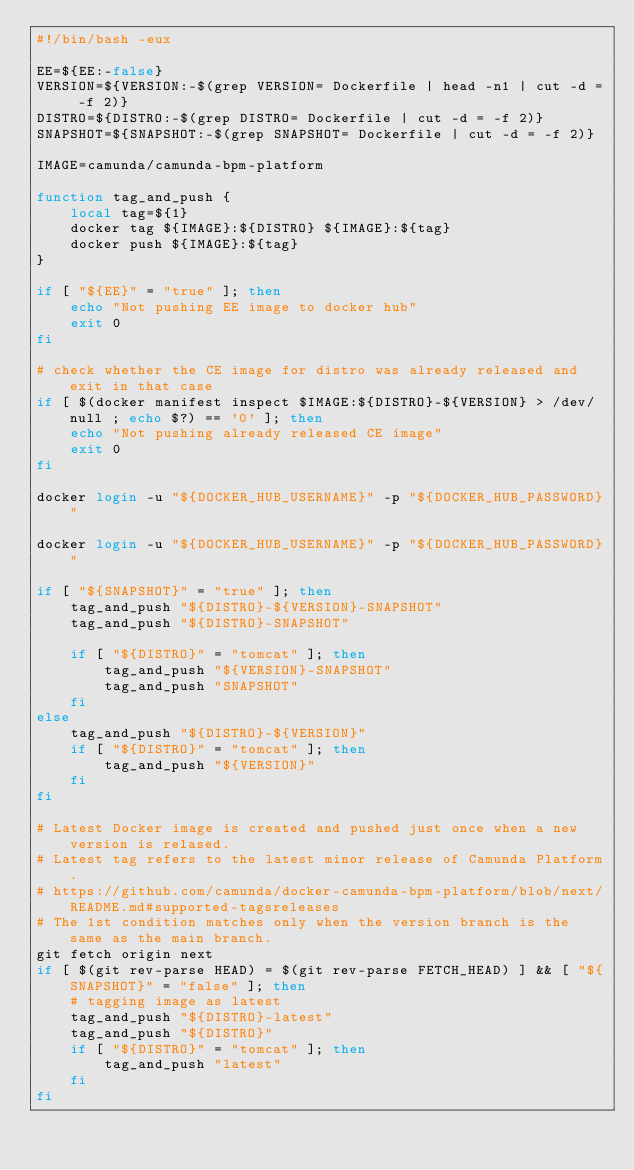Convert code to text. <code><loc_0><loc_0><loc_500><loc_500><_Bash_>#!/bin/bash -eux

EE=${EE:-false}
VERSION=${VERSION:-$(grep VERSION= Dockerfile | head -n1 | cut -d = -f 2)}
DISTRO=${DISTRO:-$(grep DISTRO= Dockerfile | cut -d = -f 2)}
SNAPSHOT=${SNAPSHOT:-$(grep SNAPSHOT= Dockerfile | cut -d = -f 2)}

IMAGE=camunda/camunda-bpm-platform

function tag_and_push {
    local tag=${1}
    docker tag ${IMAGE}:${DISTRO} ${IMAGE}:${tag}
    docker push ${IMAGE}:${tag}
}

if [ "${EE}" = "true" ]; then
    echo "Not pushing EE image to docker hub"
    exit 0
fi

# check whether the CE image for distro was already released and exit in that case
if [ $(docker manifest inspect $IMAGE:${DISTRO}-${VERSION} > /dev/null ; echo $?) == '0' ]; then
    echo "Not pushing already released CE image"
    exit 0
fi

docker login -u "${DOCKER_HUB_USERNAME}" -p "${DOCKER_HUB_PASSWORD}"

docker login -u "${DOCKER_HUB_USERNAME}" -p "${DOCKER_HUB_PASSWORD}"

if [ "${SNAPSHOT}" = "true" ]; then
    tag_and_push "${DISTRO}-${VERSION}-SNAPSHOT"
    tag_and_push "${DISTRO}-SNAPSHOT"

    if [ "${DISTRO}" = "tomcat" ]; then
        tag_and_push "${VERSION}-SNAPSHOT"
        tag_and_push "SNAPSHOT"
    fi
else
    tag_and_push "${DISTRO}-${VERSION}"
    if [ "${DISTRO}" = "tomcat" ]; then
        tag_and_push "${VERSION}"
    fi
fi

# Latest Docker image is created and pushed just once when a new version is relased.
# Latest tag refers to the latest minor release of Camunda Platform.
# https://github.com/camunda/docker-camunda-bpm-platform/blob/next/README.md#supported-tagsreleases
# The 1st condition matches only when the version branch is the same as the main branch. 
git fetch origin next
if [ $(git rev-parse HEAD) = $(git rev-parse FETCH_HEAD) ] && [ "${SNAPSHOT}" = "false" ]; then
    # tagging image as latest
    tag_and_push "${DISTRO}-latest"
    tag_and_push "${DISTRO}"
    if [ "${DISTRO}" = "tomcat" ]; then
        tag_and_push "latest"
    fi
fi
</code> 